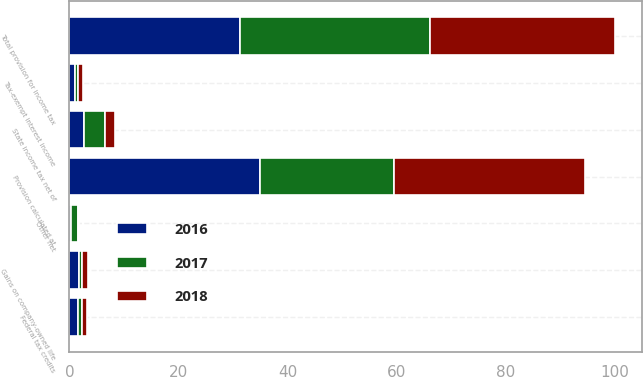Convert chart to OTSL. <chart><loc_0><loc_0><loc_500><loc_500><stacked_bar_chart><ecel><fcel>Provision calculated at<fcel>State income tax net of<fcel>Tax-exempt interest income<fcel>Gains on company-owned life<fcel>Federal tax credits<fcel>Other net<fcel>Total provision for income tax<nl><fcel>2017<fcel>24.5<fcel>3.9<fcel>0.6<fcel>0.7<fcel>0.7<fcel>1.2<fcel>34.8<nl><fcel>2016<fcel>35<fcel>2.7<fcel>1<fcel>1.7<fcel>1.6<fcel>0.3<fcel>31.2<nl><fcel>2018<fcel>35<fcel>1.7<fcel>0.9<fcel>1.1<fcel>1<fcel>0.2<fcel>33.9<nl></chart> 